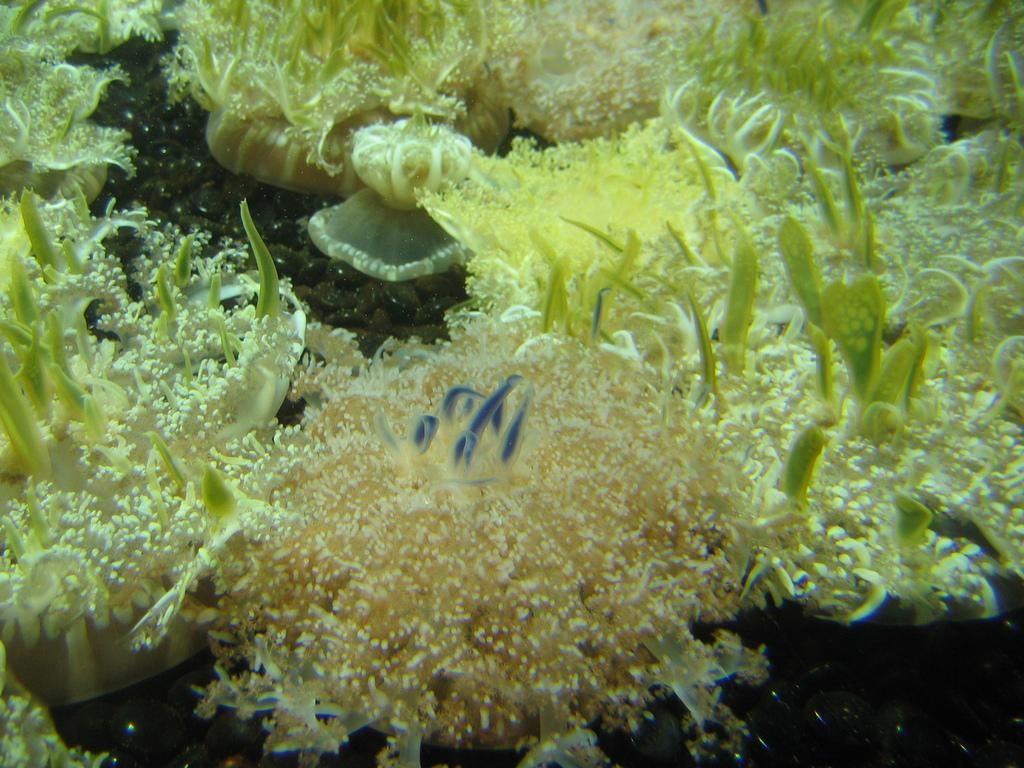What type of natural formations can be seen in the image? There are corals in the image. What other underwater features are present in the image? There are underwater plants in the image. Reasoning: Leting: Let's think step by step in order to produce the conversation. We start by identifying the main subjects in the image, which are the corals and underwater plants. Then, we formulate questions that focus on the characteristics of these subjects, ensuring that each question can be answered definitively with the information given. We avoid yes/no questions and ensure that the language is simple and clear. Absurd Question/Answer: What type of carriage can be seen in the image? There is no carriage present in the image; it is an underwater scene with corals and underwater plants. How does the band perform underwater in the image? There is no band present in the image; it is an underwater scene with corals and underwater plants. 